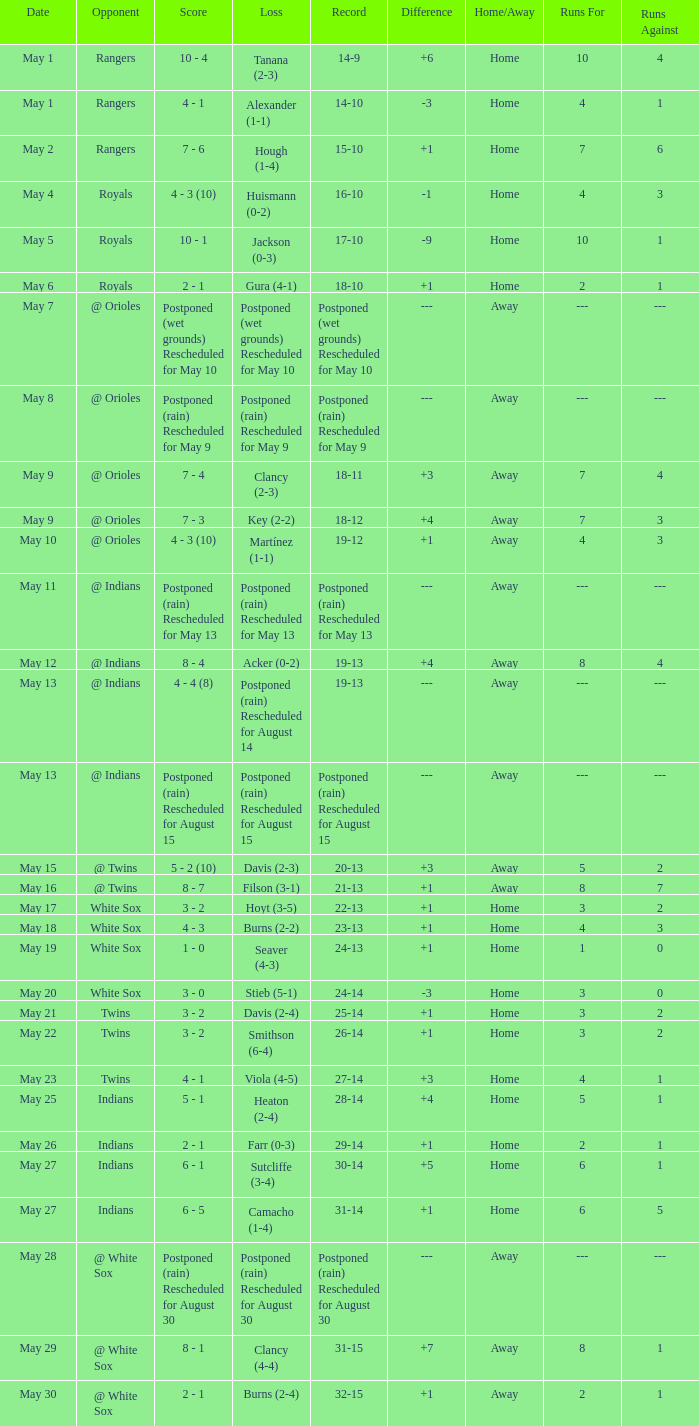What was the record at the game against the Indians with a loss of Camacho (1-4)? 31-14. 